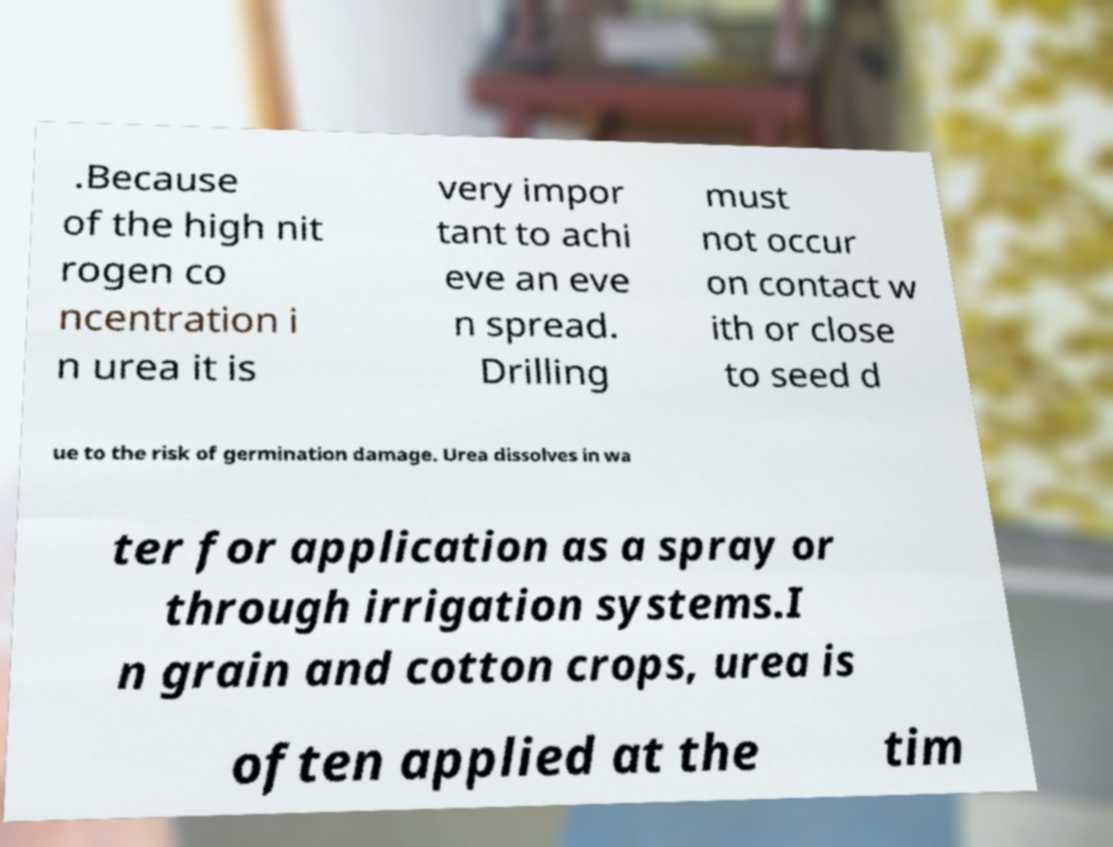What messages or text are displayed in this image? I need them in a readable, typed format. .Because of the high nit rogen co ncentration i n urea it is very impor tant to achi eve an eve n spread. Drilling must not occur on contact w ith or close to seed d ue to the risk of germination damage. Urea dissolves in wa ter for application as a spray or through irrigation systems.I n grain and cotton crops, urea is often applied at the tim 